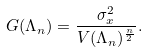Convert formula to latex. <formula><loc_0><loc_0><loc_500><loc_500>G ( \Lambda _ { n } ) = \frac { \sigma _ { x } ^ { 2 } } { V ( \Lambda _ { n } ) ^ { \frac { n } { 2 } } } .</formula> 